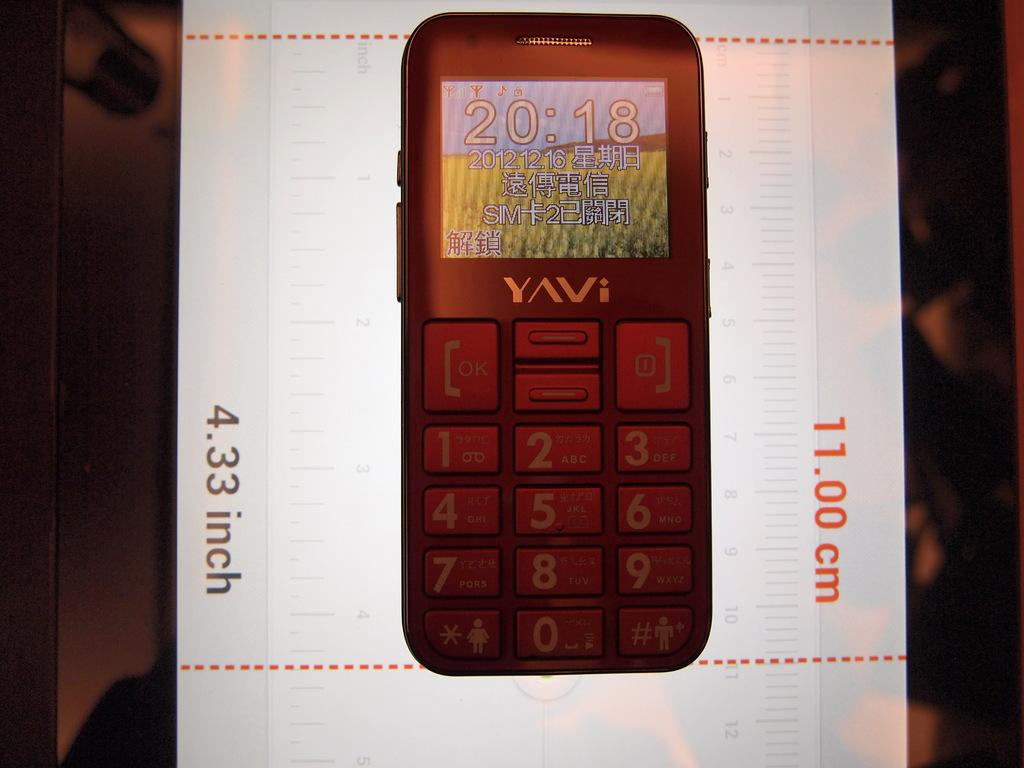<image>
Provide a brief description of the given image. A cellphone that is 11.00 cm or 4.33 inches. 